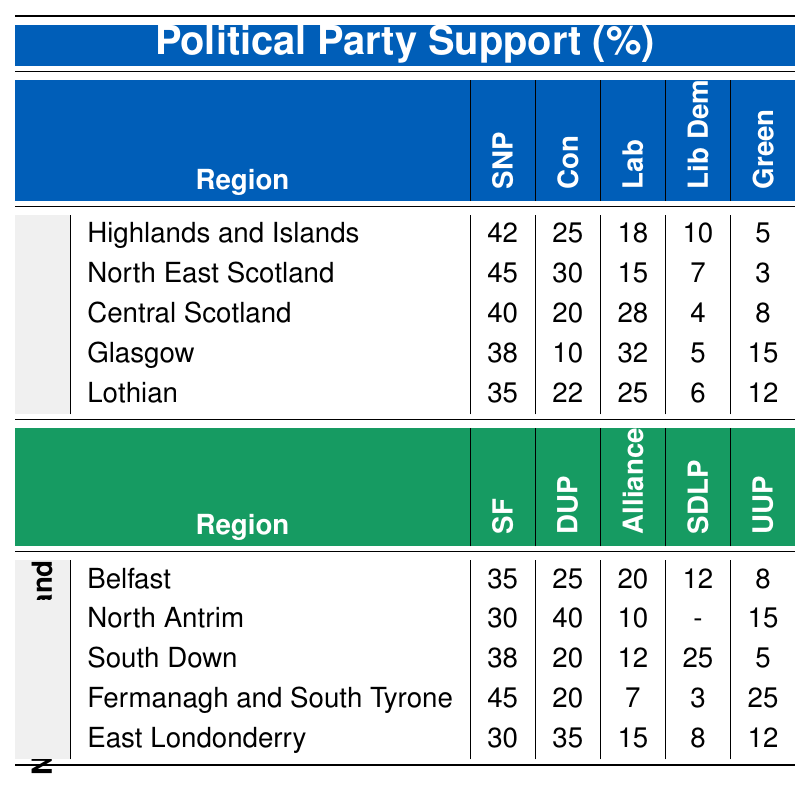What is the support percentage for the Scottish National Party in Glasgow? In the table under the "Glasgow" row under "Scotland," the percentage of support for the Scottish National Party is listed as 38%.
Answer: 38% Which region in Scotland has the highest support for the Scottish Conservatives? Looking at the Scottish Conservatives' support across regions, the highest percentage is in the "North East Scotland" column where it is listed at 30%.
Answer: 30% What percentage of support does Sinn Féin receive in Fermanagh and South Tyrone? In the "Fermanagh and South Tyrone" row under "Northern Ireland," Sinn Féin is shown to have a support percentage of 45%.
Answer: 45% Is the support for the Democratic Unionist Party higher in North Antrim or East Londonderry? North Antrim shows a support percentage of 40% for the Democratic Unionist Party, whereas East Londonderry shows 35%, meaning North Antrim has a higher percentage.
Answer: Yes What is the average support percentage for the Scottish Labour Party across all Scottish regions? Adding the support percentages for the Scottish Labour Party (18 + 15 + 28 + 32 + 25 = 118) and dividing by the number of regions (5), the average is 118 / 5 = 23.6%.
Answer: 23.6% In which region does the Scottish National Party have the lowest support? By examining all percentages for the Scottish National Party, the lowest support is found in the "Lothian" region at 35%.
Answer: 35% Which political party has the second highest support in Belfast? In the "Belfast" row, Sinn Féin has the highest support at 35%, and the Democratic Unionist Party has the second highest at 25%.
Answer: Democratic Unionist Party What is the total support percentage for the Ulster Unionist Party across all regions in Northern Ireland? The Ulster Unionist Party's percentages are 8 (Belfast) + 15 (North Antrim) + 5 (South Down) + 25 (Fermanagh and South Tyrone) + 12 (East Londonderry) = 65%.
Answer: 65% How does the Scottish Green Party's support in Glasgow compare to Central Scotland? In Glasgow, the Scottish Green Party has 15% support whereas in Central Scotland it has 8%, indicating that Glasgow has higher support.
Answer: Glasgow has higher support What is the difference in support for the Alliance Party between Belfast and South Down? The support for the Alliance Party is 20% in Belfast and 12% in South Down. The difference is 20 - 12 = 8%.
Answer: 8% 